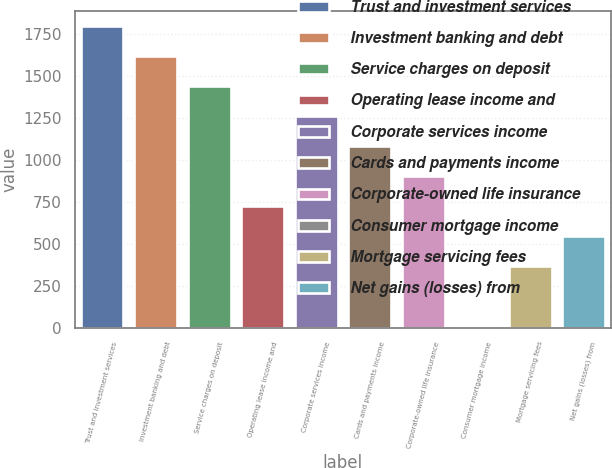Convert chart to OTSL. <chart><loc_0><loc_0><loc_500><loc_500><bar_chart><fcel>Trust and investment services<fcel>Investment banking and debt<fcel>Service charges on deposit<fcel>Operating lease income and<fcel>Corporate services income<fcel>Cards and payments income<fcel>Corporate-owned life insurance<fcel>Consumer mortgage income<fcel>Mortgage servicing fees<fcel>Net gains (losses) from<nl><fcel>1797<fcel>1618.3<fcel>1439.6<fcel>724.8<fcel>1260.9<fcel>1082.2<fcel>903.5<fcel>10<fcel>367.4<fcel>546.1<nl></chart> 